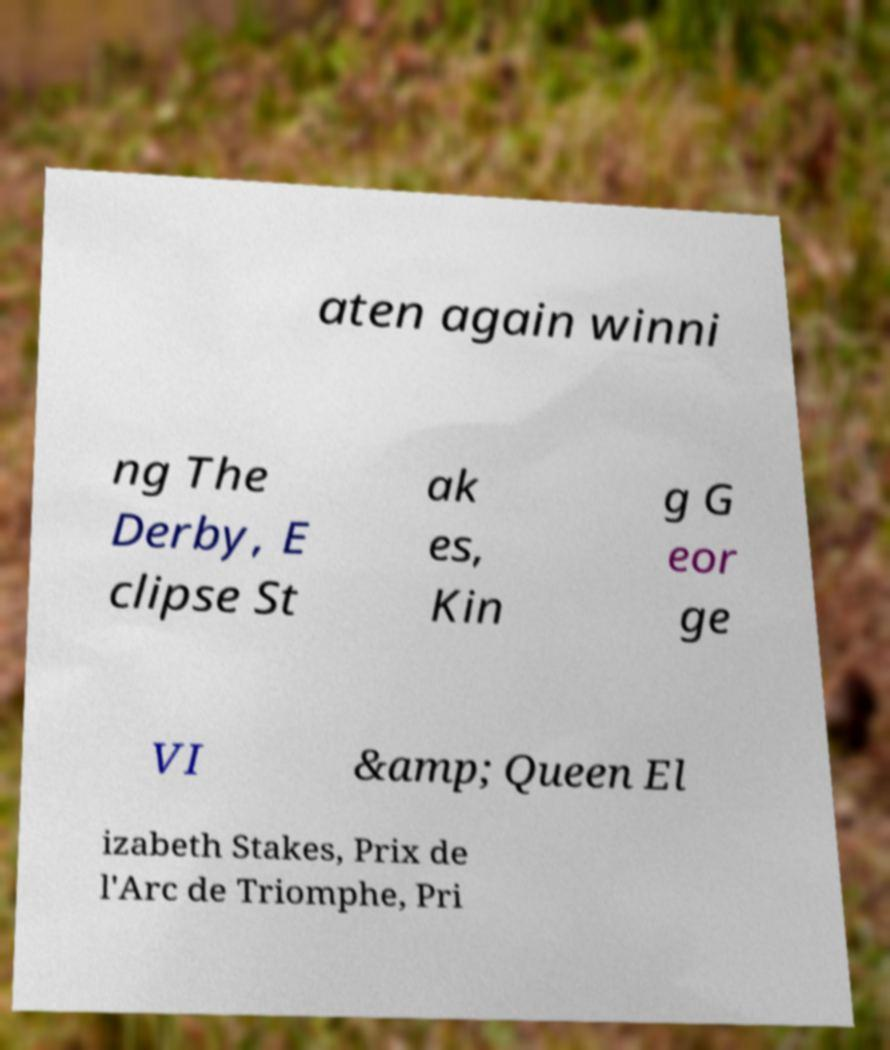There's text embedded in this image that I need extracted. Can you transcribe it verbatim? aten again winni ng The Derby, E clipse St ak es, Kin g G eor ge VI &amp; Queen El izabeth Stakes, Prix de l'Arc de Triomphe, Pri 